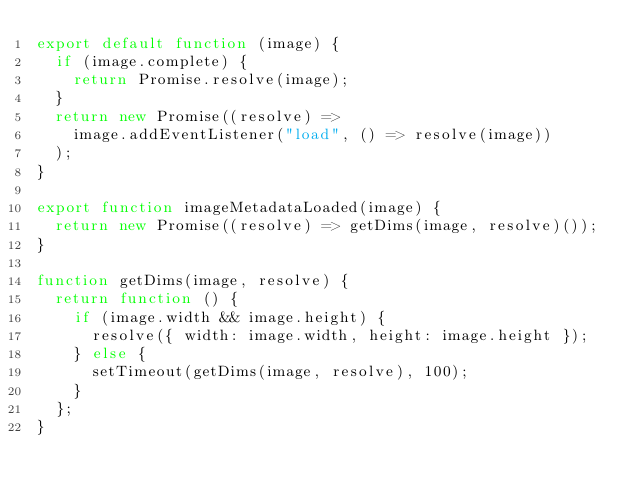Convert code to text. <code><loc_0><loc_0><loc_500><loc_500><_JavaScript_>export default function (image) {
  if (image.complete) {
    return Promise.resolve(image);
  }
  return new Promise((resolve) =>
    image.addEventListener("load", () => resolve(image))
  );
}

export function imageMetadataLoaded(image) {
  return new Promise((resolve) => getDims(image, resolve)());
}

function getDims(image, resolve) {
  return function () {
    if (image.width && image.height) {
      resolve({ width: image.width, height: image.height });
    } else {
      setTimeout(getDims(image, resolve), 100);
    }
  };
}
</code> 